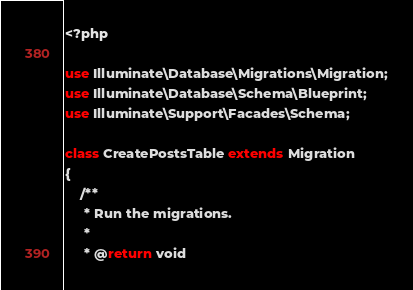Convert code to text. <code><loc_0><loc_0><loc_500><loc_500><_PHP_><?php

use Illuminate\Database\Migrations\Migration;
use Illuminate\Database\Schema\Blueprint;
use Illuminate\Support\Facades\Schema;

class CreatePostsTable extends Migration
{
    /**
     * Run the migrations.
     *
     * @return void</code> 